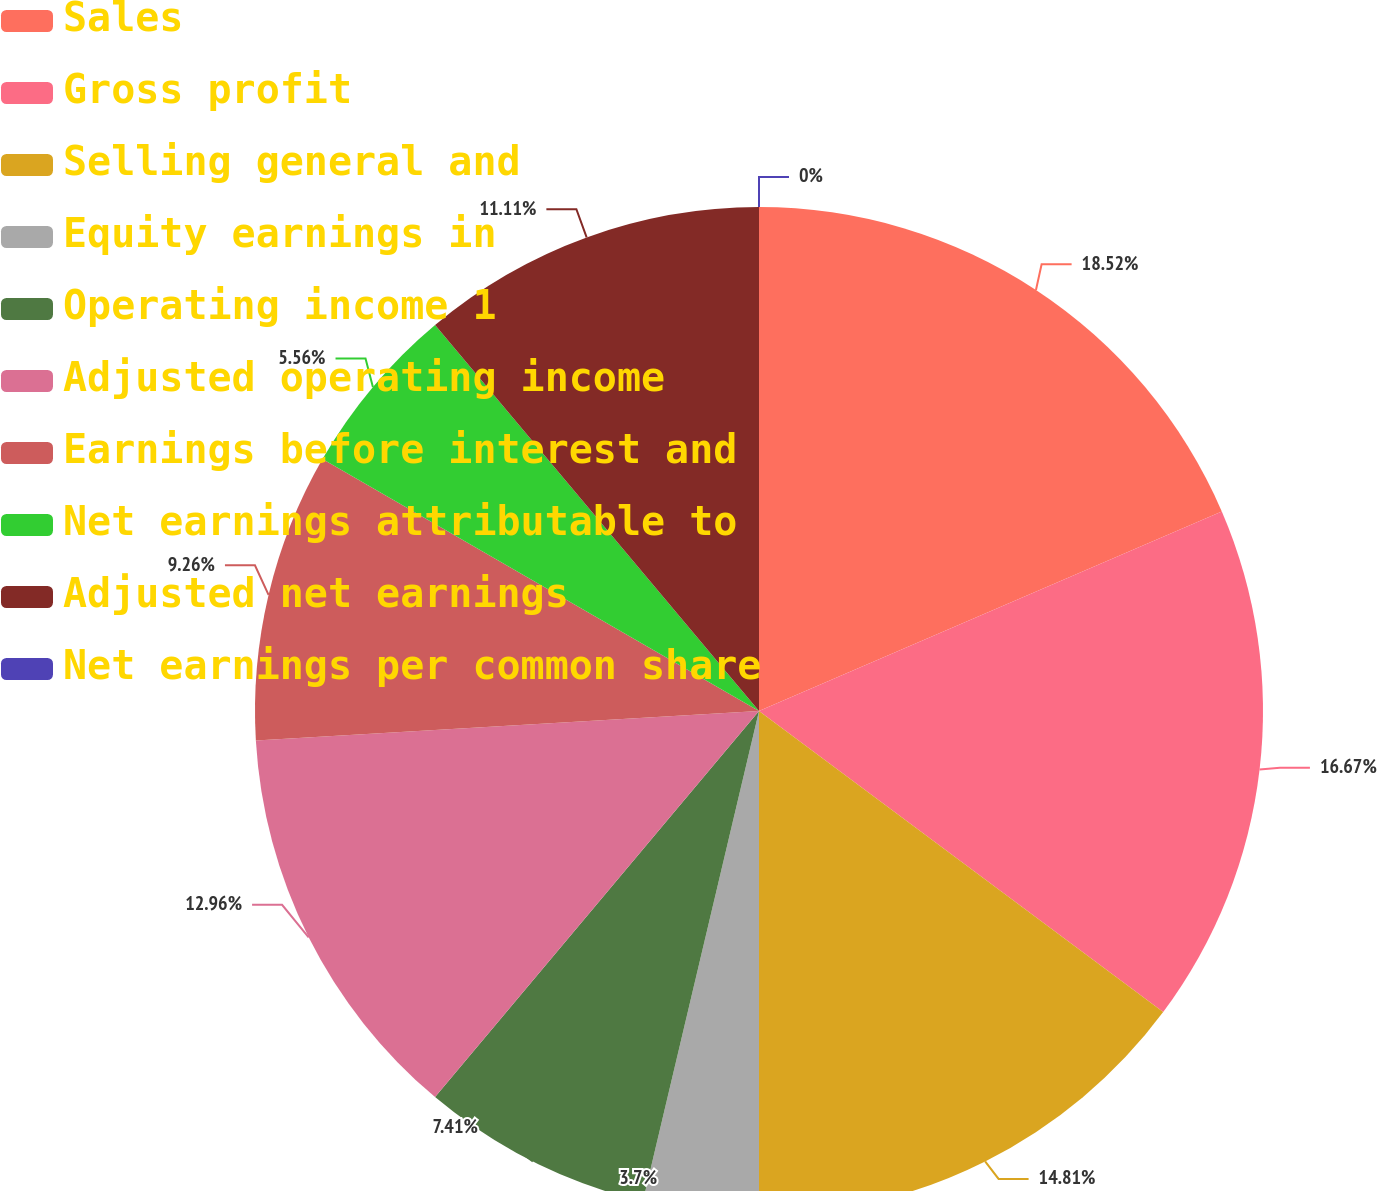<chart> <loc_0><loc_0><loc_500><loc_500><pie_chart><fcel>Sales<fcel>Gross profit<fcel>Selling general and<fcel>Equity earnings in<fcel>Operating income 1<fcel>Adjusted operating income<fcel>Earnings before interest and<fcel>Net earnings attributable to<fcel>Adjusted net earnings<fcel>Net earnings per common share<nl><fcel>18.52%<fcel>16.67%<fcel>14.81%<fcel>3.7%<fcel>7.41%<fcel>12.96%<fcel>9.26%<fcel>5.56%<fcel>11.11%<fcel>0.0%<nl></chart> 